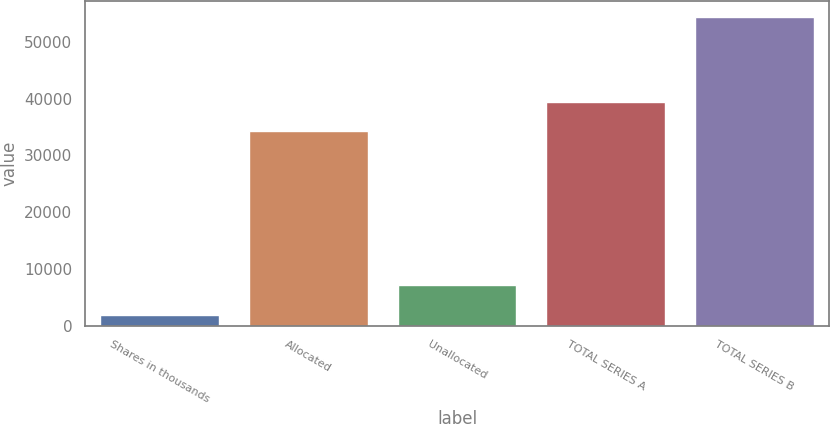Convert chart. <chart><loc_0><loc_0><loc_500><loc_500><bar_chart><fcel>Shares in thousands<fcel>Allocated<fcel>Unallocated<fcel>TOTAL SERIES A<fcel>TOTAL SERIES B<nl><fcel>2018<fcel>34233<fcel>7256.9<fcel>39471.9<fcel>54407<nl></chart> 